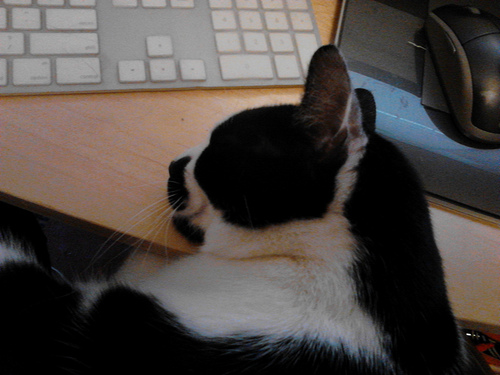<image>
Is the cat next to the mousepad? Yes. The cat is positioned adjacent to the mousepad, located nearby in the same general area. 